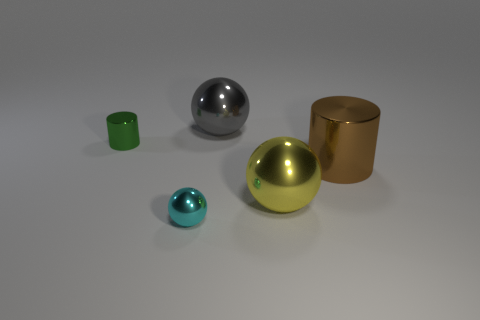Are there any cyan balls of the same size as the yellow metallic object?
Provide a succinct answer. No. There is a metal cylinder right of the green shiny cylinder; is it the same size as the yellow object?
Your answer should be very brief. Yes. Is the number of tiny yellow spheres greater than the number of cyan balls?
Provide a succinct answer. No. Is there a tiny gray thing of the same shape as the cyan object?
Provide a short and direct response. No. What shape is the large brown thing that is in front of the big gray object?
Your answer should be very brief. Cylinder. How many objects are on the right side of the big sphere that is to the right of the big thing that is behind the big brown object?
Offer a very short reply. 1. Does the big shiny sphere that is behind the green shiny cylinder have the same color as the small sphere?
Offer a very short reply. No. How many other objects are the same shape as the small cyan object?
Offer a very short reply. 2. How many other objects are the same material as the small cyan ball?
Provide a succinct answer. 4. There is a cylinder that is behind the metal cylinder that is to the right of the big metal ball that is behind the yellow thing; what is its material?
Make the answer very short. Metal. 